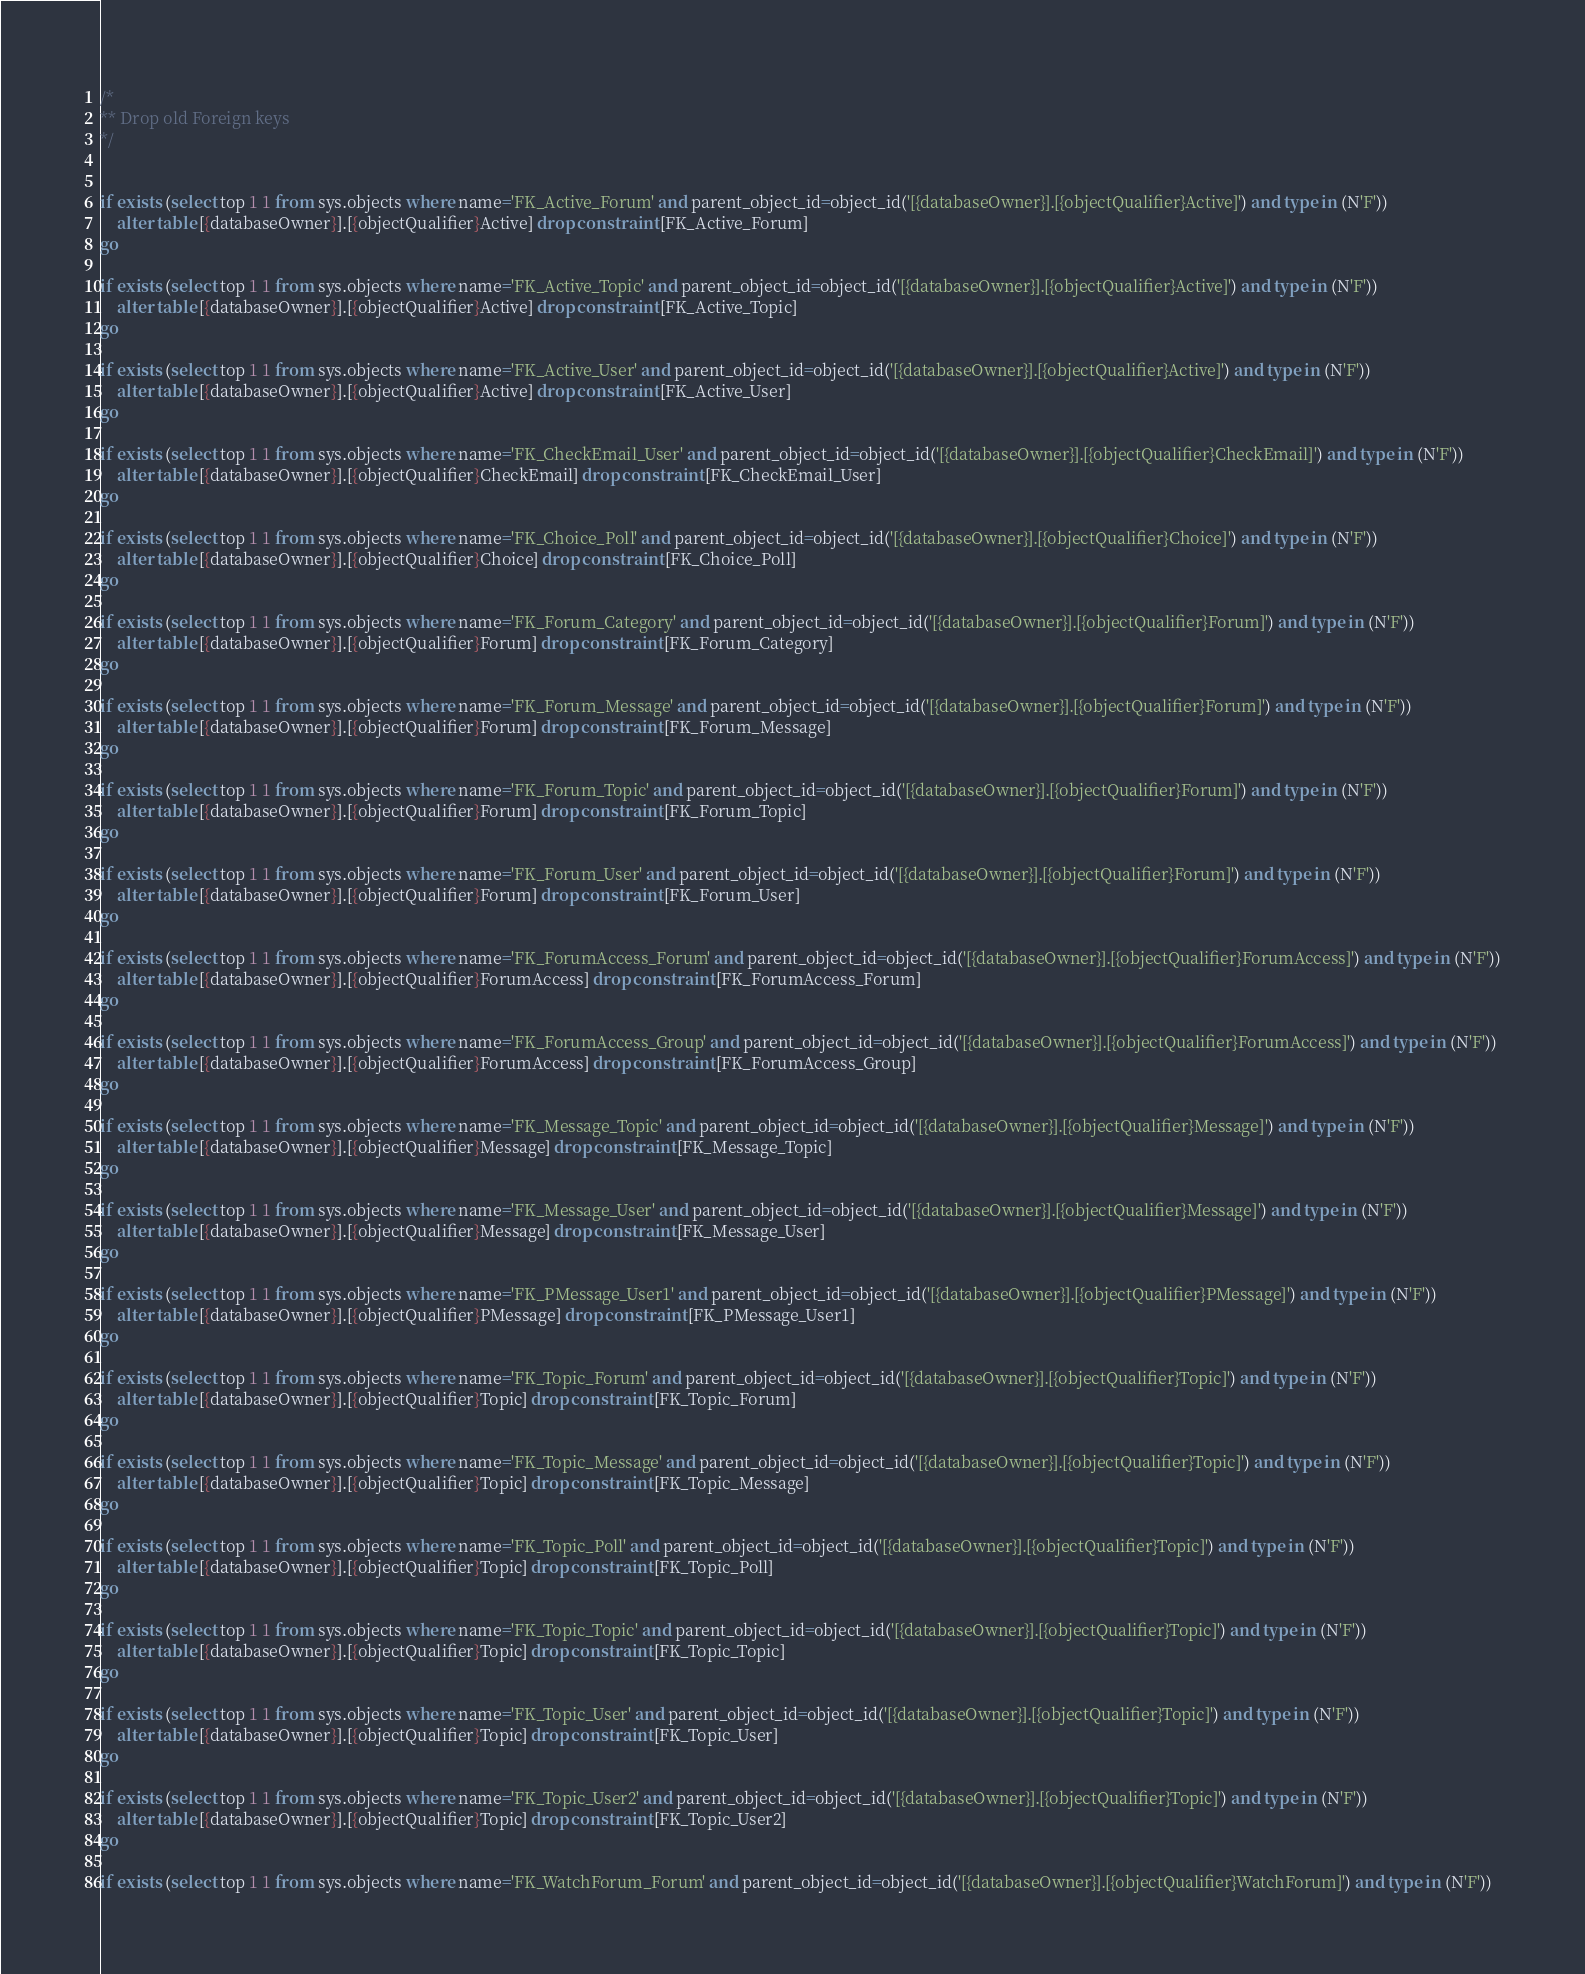<code> <loc_0><loc_0><loc_500><loc_500><_SQL_>/*
** Drop old Foreign keys
*/


if exists (select top 1 1 from sys.objects where name='FK_Active_Forum' and parent_object_id=object_id('[{databaseOwner}].[{objectQualifier}Active]') and type in (N'F'))
	alter table [{databaseOwner}].[{objectQualifier}Active] drop constraint [FK_Active_Forum]
go

if exists (select top 1 1 from sys.objects where name='FK_Active_Topic' and parent_object_id=object_id('[{databaseOwner}].[{objectQualifier}Active]') and type in (N'F'))
	alter table [{databaseOwner}].[{objectQualifier}Active] drop constraint [FK_Active_Topic]
go

if exists (select top 1 1 from sys.objects where name='FK_Active_User' and parent_object_id=object_id('[{databaseOwner}].[{objectQualifier}Active]') and type in (N'F'))
	alter table [{databaseOwner}].[{objectQualifier}Active] drop constraint [FK_Active_User]
go

if exists (select top 1 1 from sys.objects where name='FK_CheckEmail_User' and parent_object_id=object_id('[{databaseOwner}].[{objectQualifier}CheckEmail]') and type in (N'F'))
	alter table [{databaseOwner}].[{objectQualifier}CheckEmail] drop constraint [FK_CheckEmail_User]
go

if exists (select top 1 1 from sys.objects where name='FK_Choice_Poll' and parent_object_id=object_id('[{databaseOwner}].[{objectQualifier}Choice]') and type in (N'F'))
	alter table [{databaseOwner}].[{objectQualifier}Choice] drop constraint [FK_Choice_Poll]
go

if exists (select top 1 1 from sys.objects where name='FK_Forum_Category' and parent_object_id=object_id('[{databaseOwner}].[{objectQualifier}Forum]') and type in (N'F'))
	alter table [{databaseOwner}].[{objectQualifier}Forum] drop constraint [FK_Forum_Category]
go

if exists (select top 1 1 from sys.objects where name='FK_Forum_Message' and parent_object_id=object_id('[{databaseOwner}].[{objectQualifier}Forum]') and type in (N'F'))
	alter table [{databaseOwner}].[{objectQualifier}Forum] drop constraint [FK_Forum_Message]
go

if exists (select top 1 1 from sys.objects where name='FK_Forum_Topic' and parent_object_id=object_id('[{databaseOwner}].[{objectQualifier}Forum]') and type in (N'F'))
	alter table [{databaseOwner}].[{objectQualifier}Forum] drop constraint [FK_Forum_Topic]
go

if exists (select top 1 1 from sys.objects where name='FK_Forum_User' and parent_object_id=object_id('[{databaseOwner}].[{objectQualifier}Forum]') and type in (N'F'))
	alter table [{databaseOwner}].[{objectQualifier}Forum] drop constraint [FK_Forum_User]
go

if exists (select top 1 1 from sys.objects where name='FK_ForumAccess_Forum' and parent_object_id=object_id('[{databaseOwner}].[{objectQualifier}ForumAccess]') and type in (N'F'))
	alter table [{databaseOwner}].[{objectQualifier}ForumAccess] drop constraint [FK_ForumAccess_Forum]
go

if exists (select top 1 1 from sys.objects where name='FK_ForumAccess_Group' and parent_object_id=object_id('[{databaseOwner}].[{objectQualifier}ForumAccess]') and type in (N'F'))
	alter table [{databaseOwner}].[{objectQualifier}ForumAccess] drop constraint [FK_ForumAccess_Group]
go

if exists (select top 1 1 from sys.objects where name='FK_Message_Topic' and parent_object_id=object_id('[{databaseOwner}].[{objectQualifier}Message]') and type in (N'F'))
	alter table [{databaseOwner}].[{objectQualifier}Message] drop constraint [FK_Message_Topic]
go

if exists (select top 1 1 from sys.objects where name='FK_Message_User' and parent_object_id=object_id('[{databaseOwner}].[{objectQualifier}Message]') and type in (N'F'))
	alter table [{databaseOwner}].[{objectQualifier}Message] drop constraint [FK_Message_User]
go

if exists (select top 1 1 from sys.objects where name='FK_PMessage_User1' and parent_object_id=object_id('[{databaseOwner}].[{objectQualifier}PMessage]') and type in (N'F'))
	alter table [{databaseOwner}].[{objectQualifier}PMessage] drop constraint [FK_PMessage_User1]
go

if exists (select top 1 1 from sys.objects where name='FK_Topic_Forum' and parent_object_id=object_id('[{databaseOwner}].[{objectQualifier}Topic]') and type in (N'F'))
	alter table [{databaseOwner}].[{objectQualifier}Topic] drop constraint [FK_Topic_Forum]
go

if exists (select top 1 1 from sys.objects where name='FK_Topic_Message' and parent_object_id=object_id('[{databaseOwner}].[{objectQualifier}Topic]') and type in (N'F'))
	alter table [{databaseOwner}].[{objectQualifier}Topic] drop constraint [FK_Topic_Message]
go

if exists (select top 1 1 from sys.objects where name='FK_Topic_Poll' and parent_object_id=object_id('[{databaseOwner}].[{objectQualifier}Topic]') and type in (N'F'))
	alter table [{databaseOwner}].[{objectQualifier}Topic] drop constraint [FK_Topic_Poll]
go

if exists (select top 1 1 from sys.objects where name='FK_Topic_Topic' and parent_object_id=object_id('[{databaseOwner}].[{objectQualifier}Topic]') and type in (N'F'))
	alter table [{databaseOwner}].[{objectQualifier}Topic] drop constraint [FK_Topic_Topic]
go

if exists (select top 1 1 from sys.objects where name='FK_Topic_User' and parent_object_id=object_id('[{databaseOwner}].[{objectQualifier}Topic]') and type in (N'F'))
	alter table [{databaseOwner}].[{objectQualifier}Topic] drop constraint [FK_Topic_User]
go

if exists (select top 1 1 from sys.objects where name='FK_Topic_User2' and parent_object_id=object_id('[{databaseOwner}].[{objectQualifier}Topic]') and type in (N'F'))
	alter table [{databaseOwner}].[{objectQualifier}Topic] drop constraint [FK_Topic_User2]
go

if exists (select top 1 1 from sys.objects where name='FK_WatchForum_Forum' and parent_object_id=object_id('[{databaseOwner}].[{objectQualifier}WatchForum]') and type in (N'F'))</code> 